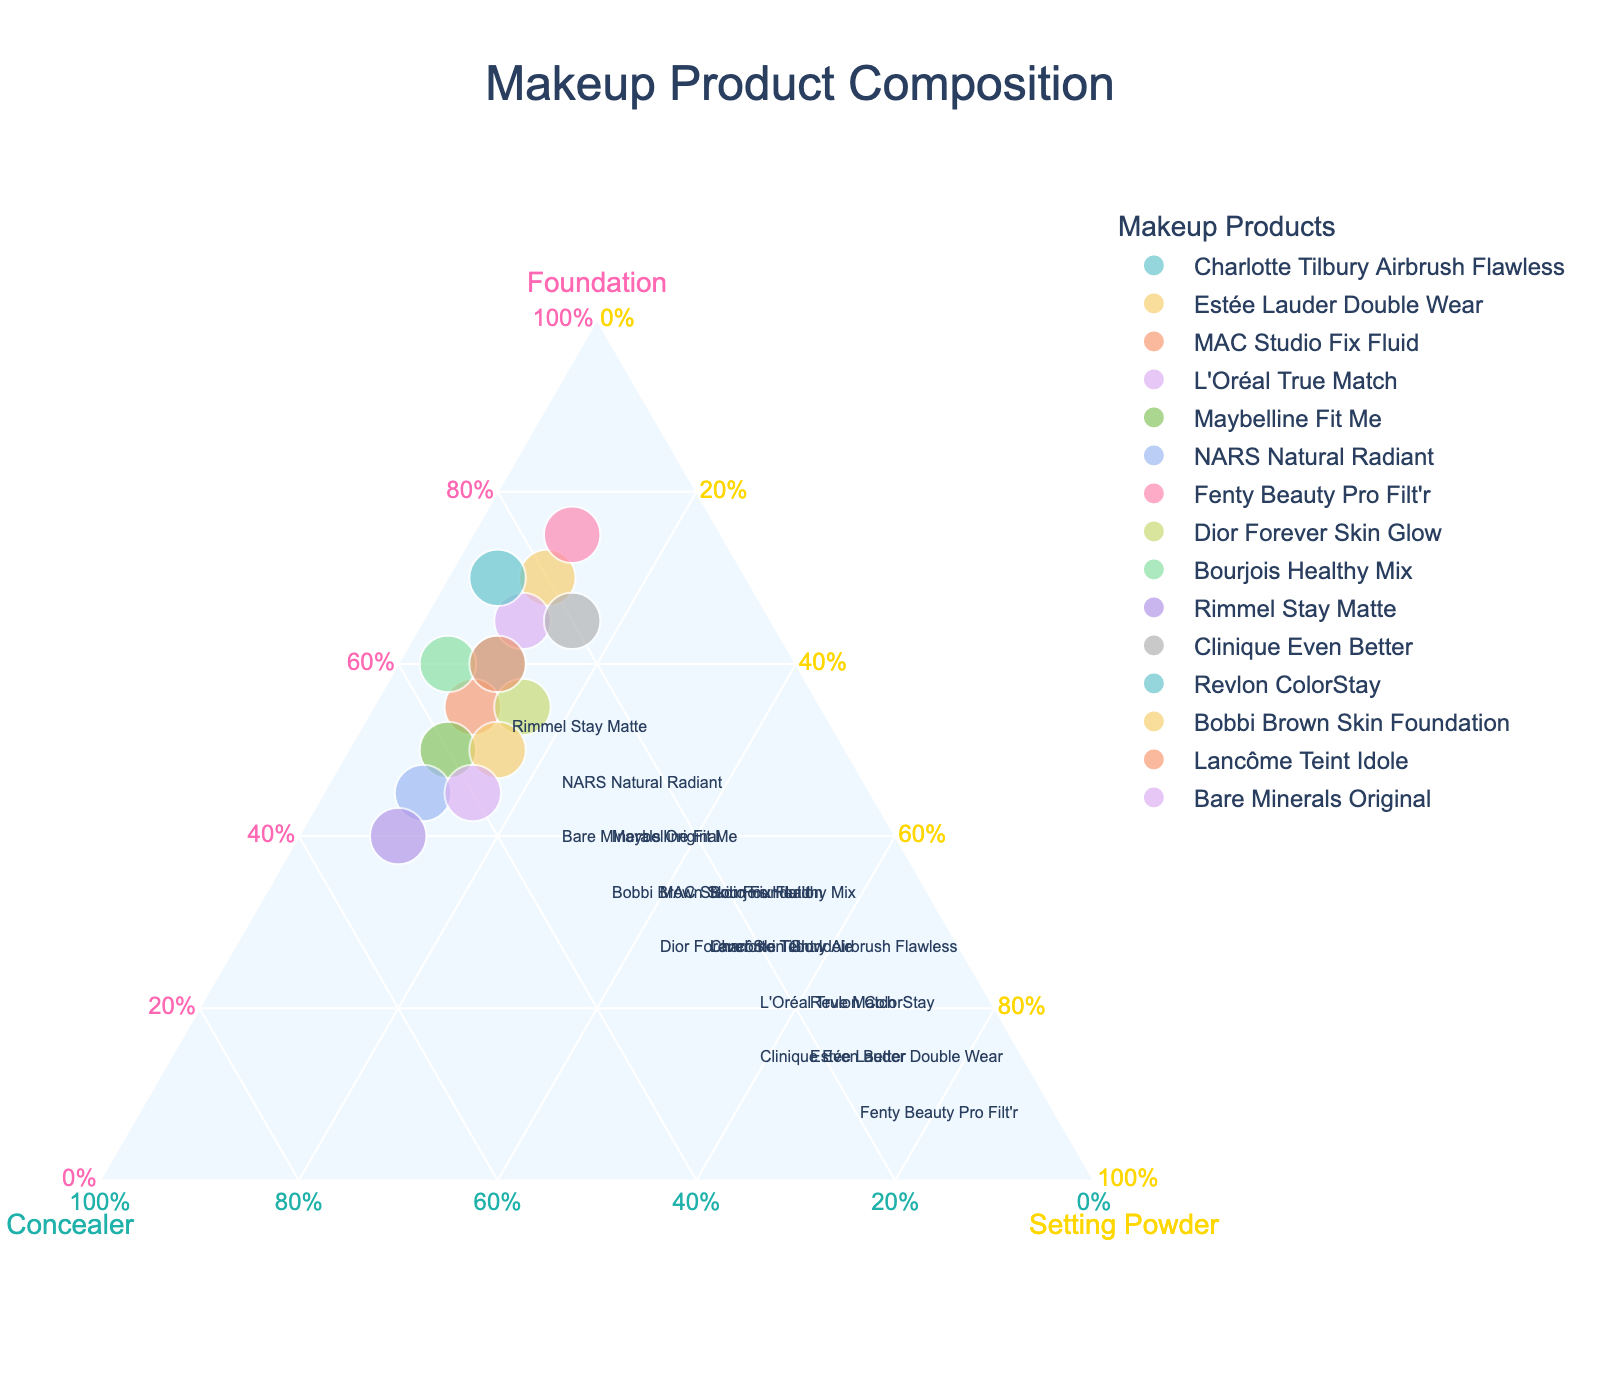Which product has the highest ratio of foundation? Looking at the plot, the product with the point placed farthest from the line connecting the "Concealer" and "Setting Powder" corners has the highest ratio of foundation.
Answer: Fenty Beauty Pro Filt'r Which two products have equal ratios for concealer and setting powder? Products will be located along a line parallel to the "Foundation" axis for equal ratios of concealer and setting powder.
Answer: Charlotte Tilbury Airbrush Flawless, Estée Lauder Double Wear What is the total foundation ratio added up for Maybelline Fit Me and Bourjois Healthy Mix? The foundation ratio for Maybelline Fit Me is 50%. The foundation ratio for Bourjois Healthy Mix is 60%. Adding these two gives (50% + 60%) = 110%
Answer: 110% Which products have the same ratio for foundation? Products on the same horizontal level (relative to the "Foundation" axis) have the same foundation ratio.
Answer: Bobbi Brown Skin Foundation, Maybelline Fit Me What is the difference in concealer ratio between MAC Studio Fix Fluid and Dior Forever Skin Glow? MAC Studio Fix Fluid has a concealer ratio of 35%. Dior Forever Skin Glow has a concealer ratio of 30%. The difference is 35% - 30% = 5%
Answer: 5% Which product has the most balanced composition of all three components? The product closest to the center of the ternary plot has the most balanced composition.
Answer: Rimmel Stay Matte How do the concealer ratios of L'Oréal True Match and Clinique Even Better compare? L'Oréal True Match has a concealer ratio of 25%. Clinique Even Better has a concealer ratio of 20%. Therefore, L'Oréal True Match's ratio is higher.
Answer: L'Oréal True Match has a higher concealer ratio Which products have the lowest ratio of setting powder? Products located close to the "Foundation"-"Concealer" edge (opposite the "Setting Powder" corner) have the lowest setting powder ratio.
Answer: Bourjois Healthy Mix, Revlon ColorStay What fraction of the total does the concealer ratio represent for NARS Natural Radiant? Since all ratios sum to 100% and NARS Natural Radiant has equal foundation and concealer ratios at 45%, the fraction for the concealer ratio can be expressed as the ratio itself, \( 45 / 100 = 0.45 \).
Answer: 0.45 